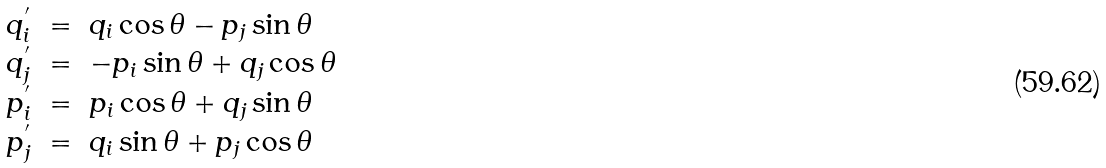Convert formula to latex. <formula><loc_0><loc_0><loc_500><loc_500>\begin{array} { l l l } q _ { i } ^ { ^ { \prime } } & = & q _ { i } \cos \theta - p _ { j } \sin \theta \\ q _ { j } ^ { ^ { \prime } } & = & - p _ { i } \sin \theta + q _ { j } \cos \theta \\ p _ { i } ^ { ^ { \prime } } & = & p _ { i } \cos \theta + q _ { j } \sin \theta \\ p _ { j } ^ { ^ { \prime } } & = & q _ { i } \sin \theta + p _ { j } \cos \theta \end{array}</formula> 